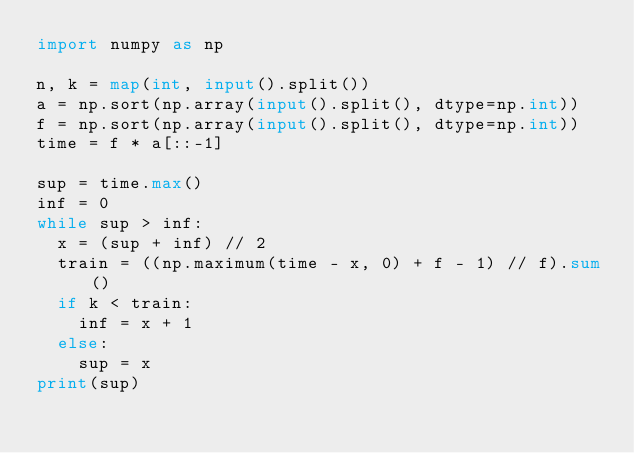Convert code to text. <code><loc_0><loc_0><loc_500><loc_500><_Python_>import numpy as np

n, k = map(int, input().split())
a = np.sort(np.array(input().split(), dtype=np.int))
f = np.sort(np.array(input().split(), dtype=np.int))
time = f * a[::-1]

sup = time.max()
inf = 0
while sup > inf:
  x = (sup + inf) // 2
  train = ((np.maximum(time - x, 0) + f - 1) // f).sum()
  if k < train:
    inf = x + 1
  else:
    sup = x
print(sup)</code> 